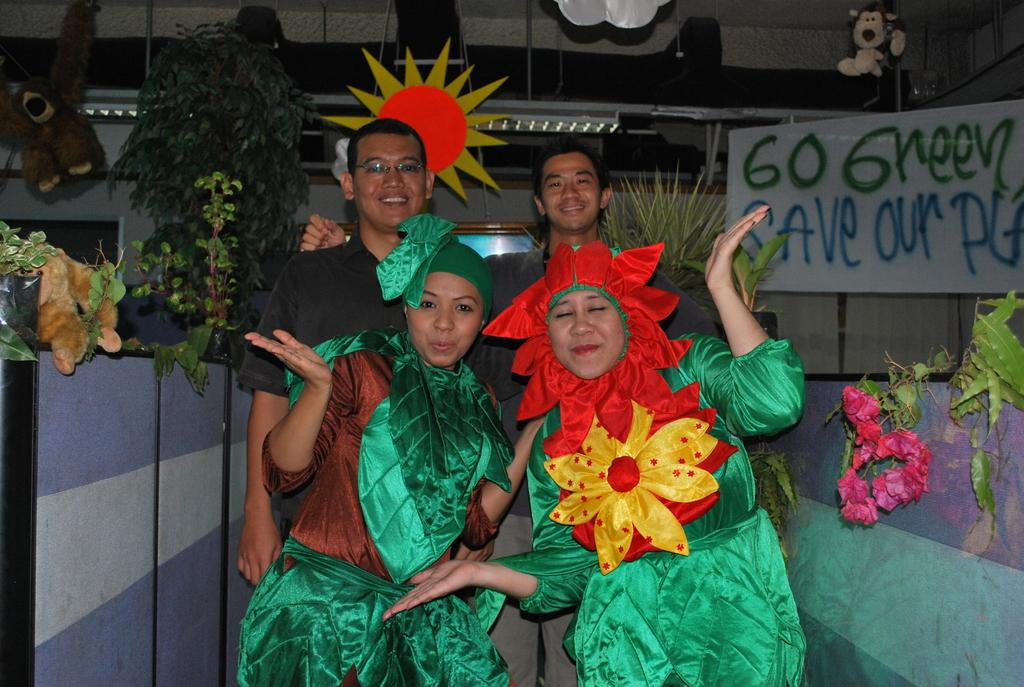How many people are in the image? There are four people in the image, two women and two men. What are the women wearing in the image? The women are wearing costumes in the image. What expressions do the men have in the image? The men are smiling in the image. What can be seen on either side of the image? There are plants and dolls on either side of the image. Can you describe the cloud formation in the image? There is no cloud formation present in the image. 